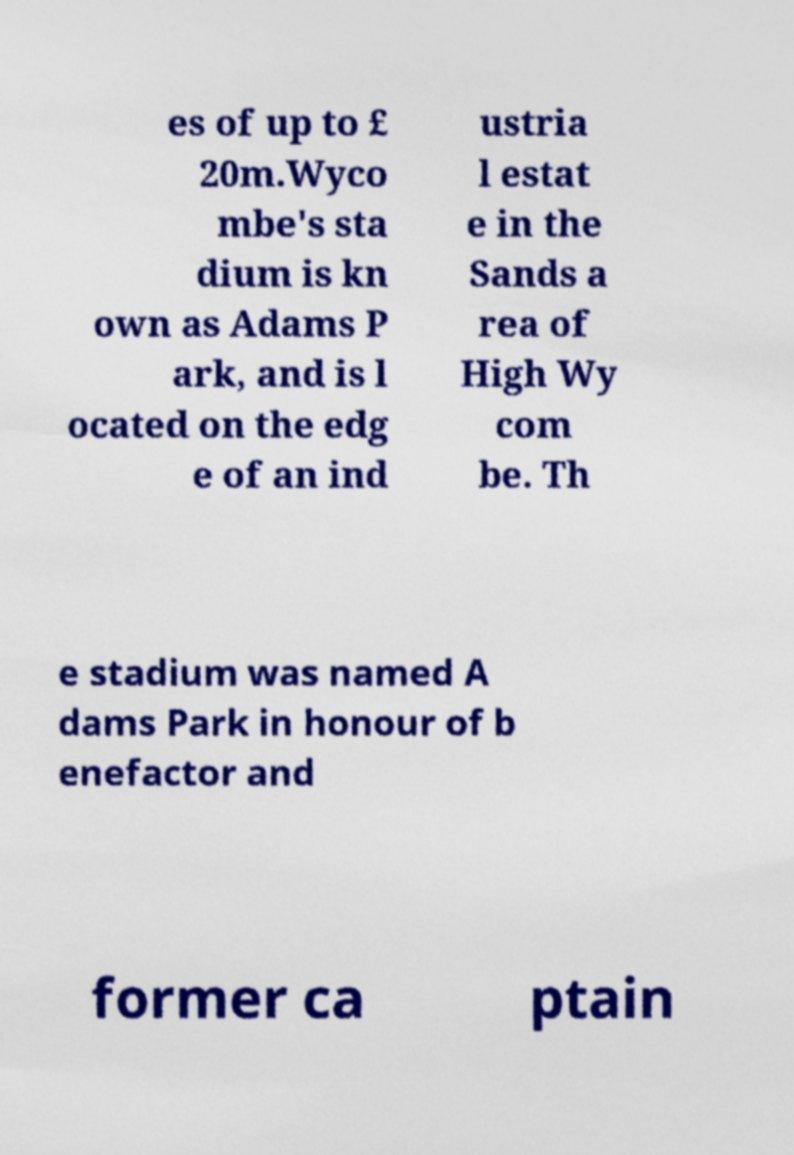Could you extract and type out the text from this image? es of up to £ 20m.Wyco mbe's sta dium is kn own as Adams P ark, and is l ocated on the edg e of an ind ustria l estat e in the Sands a rea of High Wy com be. Th e stadium was named A dams Park in honour of b enefactor and former ca ptain 